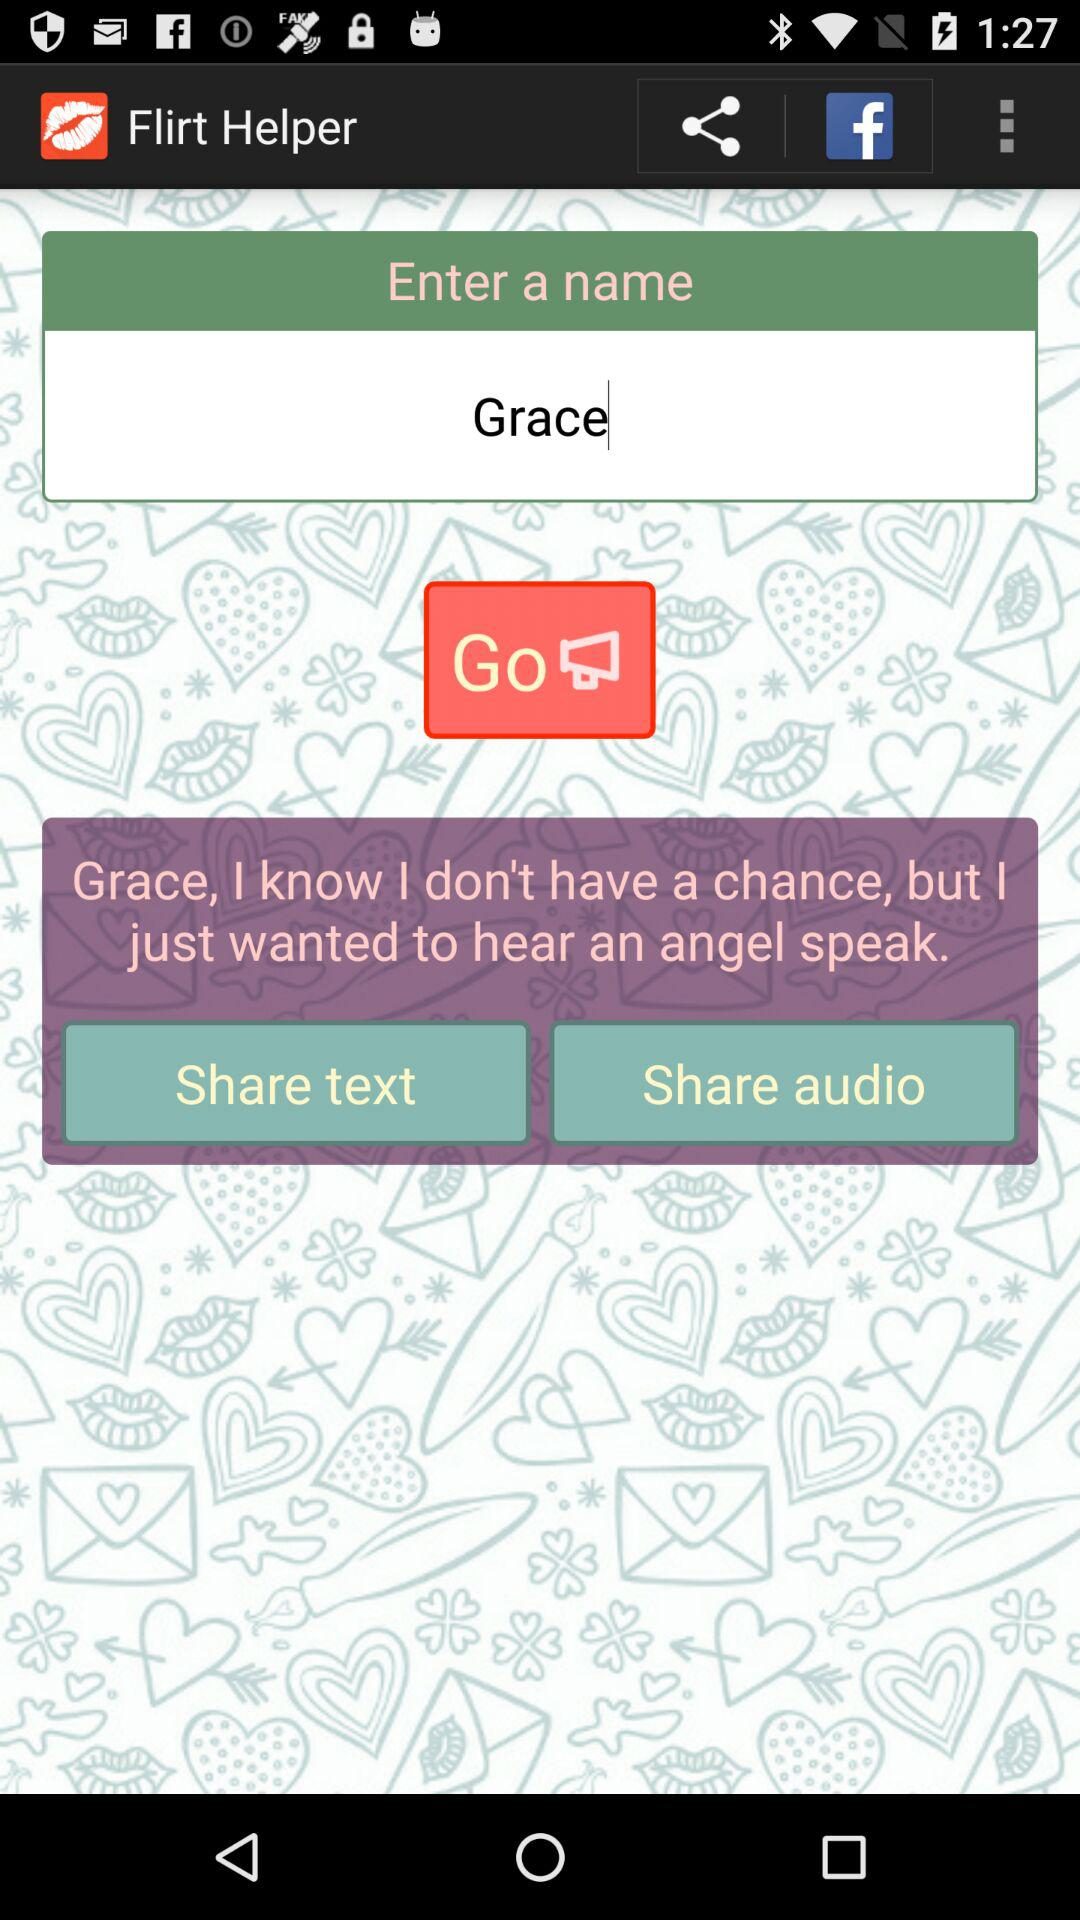What is the user name? The user name is Grace. 